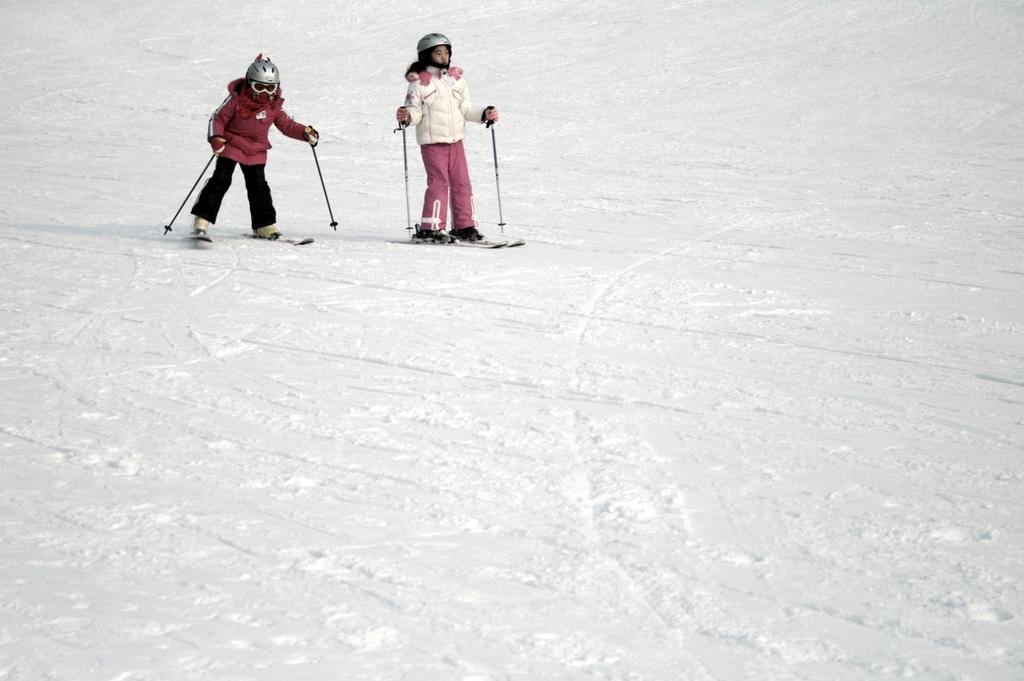How many people are in the image? There are two persons in the image. What are the persons wearing on their heads? The persons are wearing helmets. What activity are the persons engaged in? The persons are skiing on the ice. What is the surface they are skiing on? There is ice on the ground. What type of ornament is hanging from the lamp in the image? There is no lamp or ornament present in the image. What kind of mask is the person wearing in the image? There are no masks visible in the image; the persons are wearing helmets for skiing. 